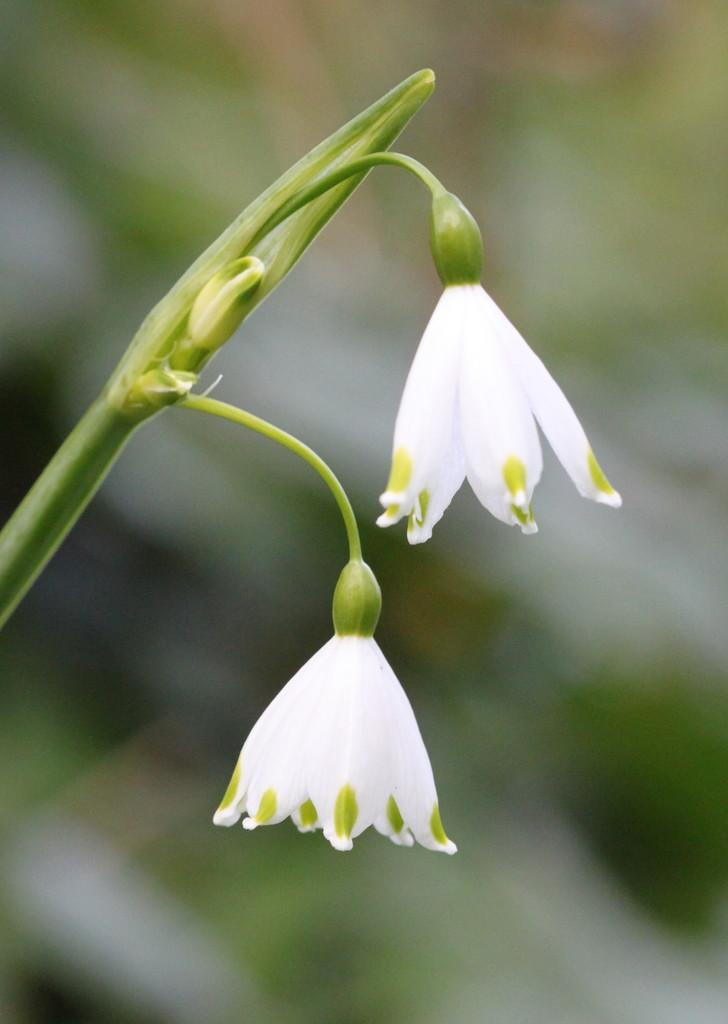What type of plants can be seen in the image? There are flowers in the image. What part of the flowers is visible in the image? There are stems in the image. Can you describe the background of the image? The background of the image is blurry. How many legs can be seen supporting the flowers in the image? There are no legs visible in the image; the flowers are likely in a vase or on the ground. 